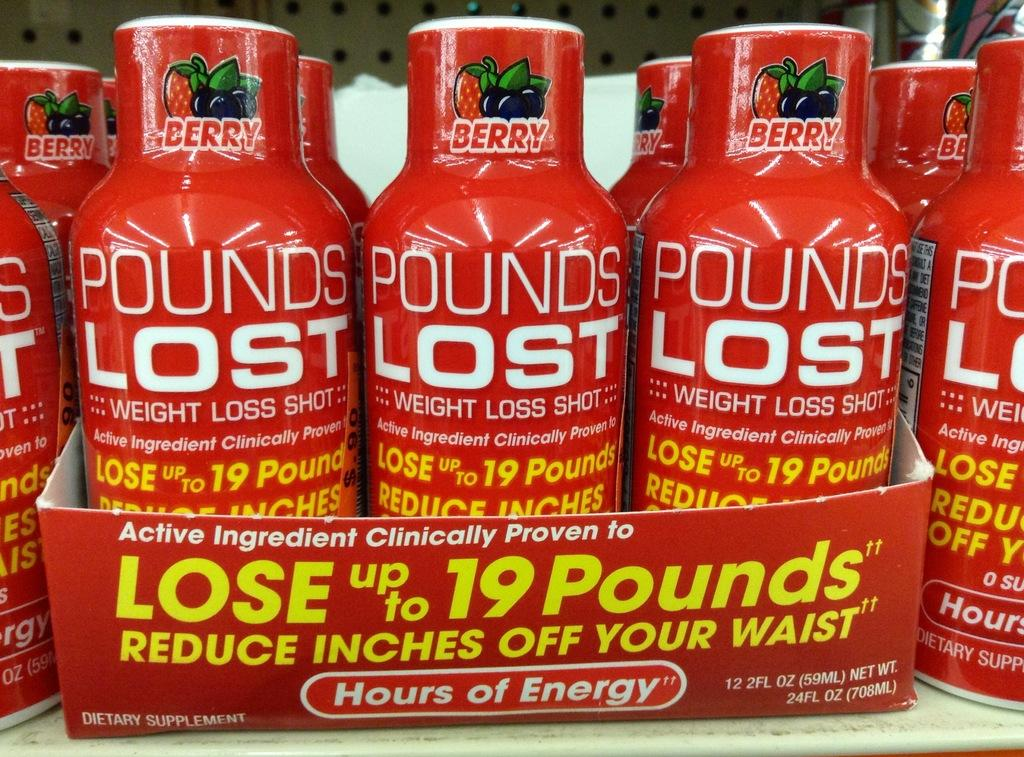Provide a one-sentence caption for the provided image. Four bottles on display three of which are in a case and they are red with white letters that say Pounds Lost on the front. 